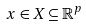<formula> <loc_0><loc_0><loc_500><loc_500>x \in X \subseteq \mathbb { R } ^ { p }</formula> 